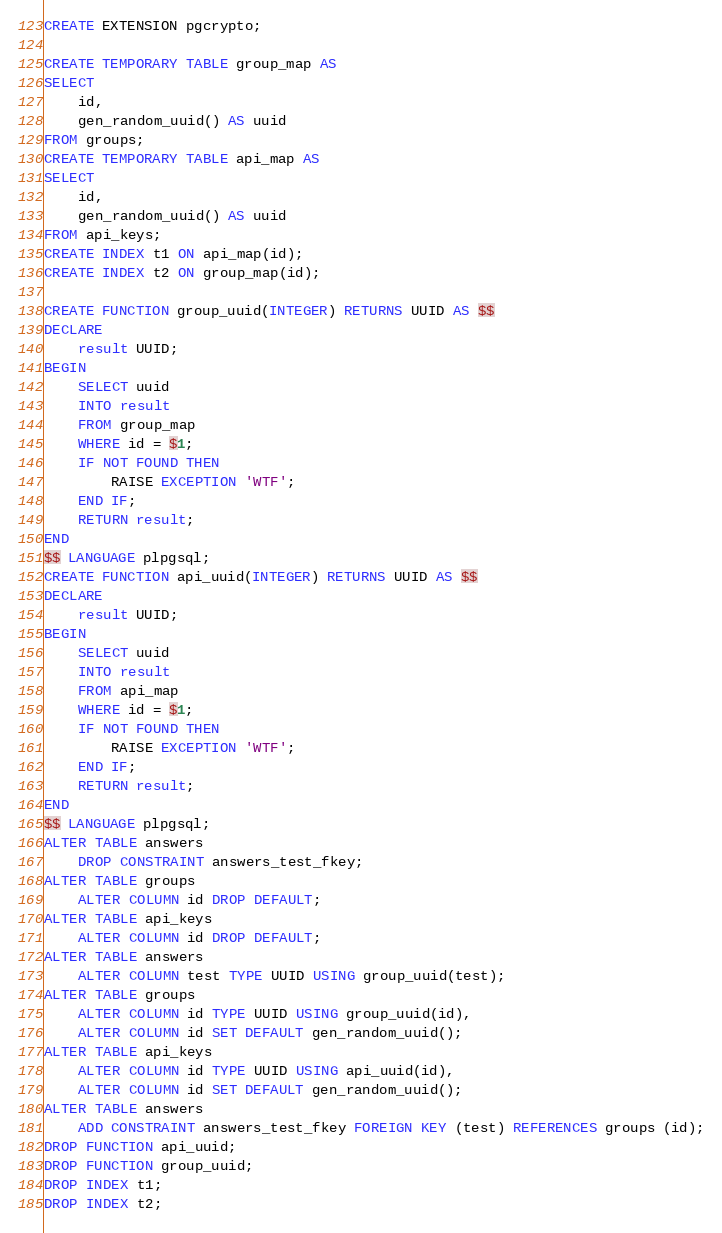<code> <loc_0><loc_0><loc_500><loc_500><_SQL_>CREATE EXTENSION pgcrypto;

CREATE TEMPORARY TABLE group_map AS
SELECT
    id,
    gen_random_uuid() AS uuid
FROM groups;
CREATE TEMPORARY TABLE api_map AS
SELECT
    id,
    gen_random_uuid() AS uuid
FROM api_keys;
CREATE INDEX t1 ON api_map(id);
CREATE INDEX t2 ON group_map(id);

CREATE FUNCTION group_uuid(INTEGER) RETURNS UUID AS $$
DECLARE
    result UUID;
BEGIN
    SELECT uuid
    INTO result
    FROM group_map
    WHERE id = $1;
    IF NOT FOUND THEN
        RAISE EXCEPTION 'WTF';
    END IF;
    RETURN result;
END
$$ LANGUAGE plpgsql;
CREATE FUNCTION api_uuid(INTEGER) RETURNS UUID AS $$
DECLARE
    result UUID;
BEGIN
    SELECT uuid
    INTO result
    FROM api_map
    WHERE id = $1;
    IF NOT FOUND THEN
        RAISE EXCEPTION 'WTF';
    END IF;
    RETURN result;
END
$$ LANGUAGE plpgsql;
ALTER TABLE answers
    DROP CONSTRAINT answers_test_fkey;
ALTER TABLE groups
    ALTER COLUMN id DROP DEFAULT;
ALTER TABLE api_keys
    ALTER COLUMN id DROP DEFAULT;
ALTER TABLE answers
    ALTER COLUMN test TYPE UUID USING group_uuid(test);
ALTER TABLE groups
    ALTER COLUMN id TYPE UUID USING group_uuid(id),
    ALTER COLUMN id SET DEFAULT gen_random_uuid();
ALTER TABLE api_keys
    ALTER COLUMN id TYPE UUID USING api_uuid(id),
    ALTER COLUMN id SET DEFAULT gen_random_uuid();
ALTER TABLE answers
    ADD CONSTRAINT answers_test_fkey FOREIGN KEY (test) REFERENCES groups (id);
DROP FUNCTION api_uuid;
DROP FUNCTION group_uuid;
DROP INDEX t1;
DROP INDEX t2;
</code> 